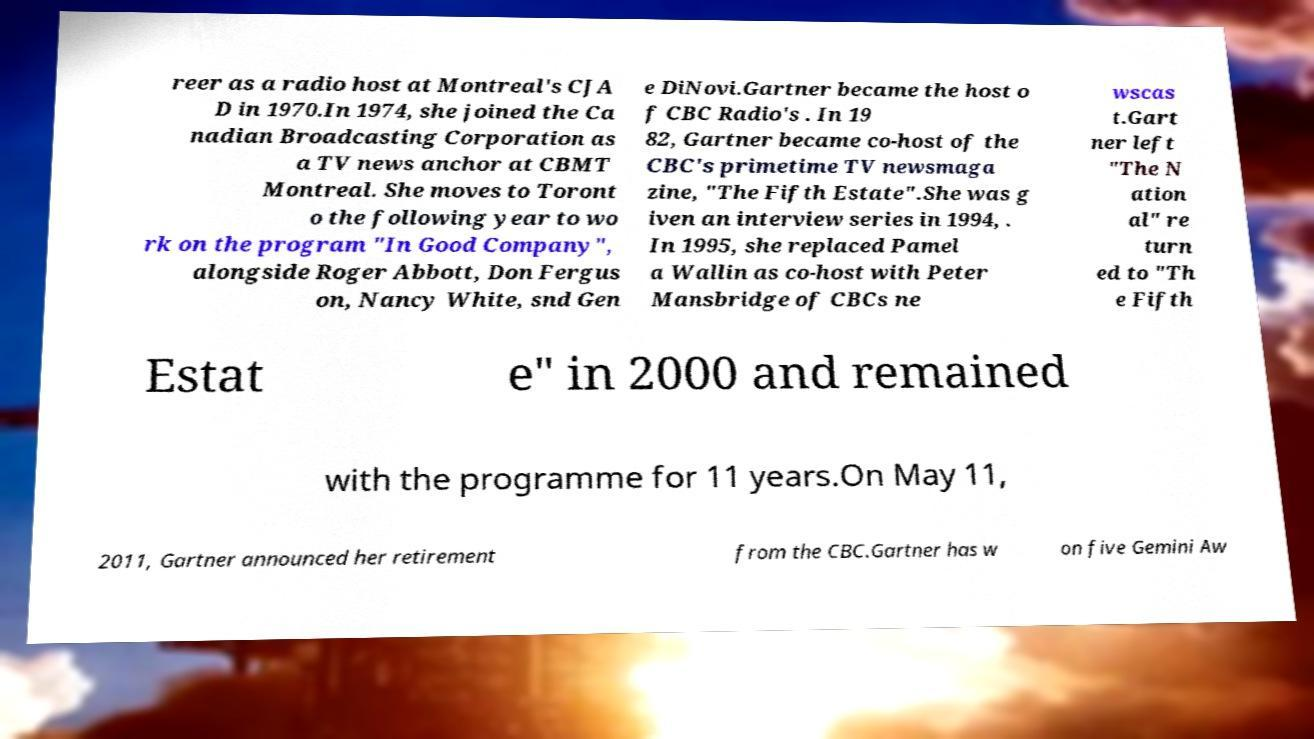For documentation purposes, I need the text within this image transcribed. Could you provide that? reer as a radio host at Montreal's CJA D in 1970.In 1974, she joined the Ca nadian Broadcasting Corporation as a TV news anchor at CBMT Montreal. She moves to Toront o the following year to wo rk on the program "In Good Company", alongside Roger Abbott, Don Fergus on, Nancy White, snd Gen e DiNovi.Gartner became the host o f CBC Radio's . In 19 82, Gartner became co-host of the CBC's primetime TV newsmaga zine, "The Fifth Estate".She was g iven an interview series in 1994, . In 1995, she replaced Pamel a Wallin as co-host with Peter Mansbridge of CBCs ne wscas t.Gart ner left "The N ation al" re turn ed to "Th e Fifth Estat e" in 2000 and remained with the programme for 11 years.On May 11, 2011, Gartner announced her retirement from the CBC.Gartner has w on five Gemini Aw 